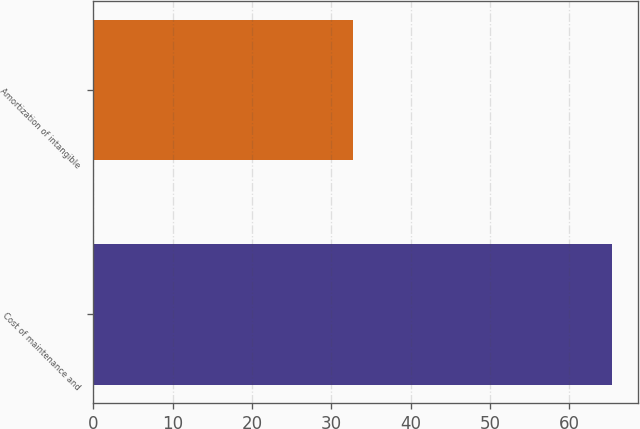<chart> <loc_0><loc_0><loc_500><loc_500><bar_chart><fcel>Cost of maintenance and<fcel>Amortization of intangible<nl><fcel>65.4<fcel>32.7<nl></chart> 